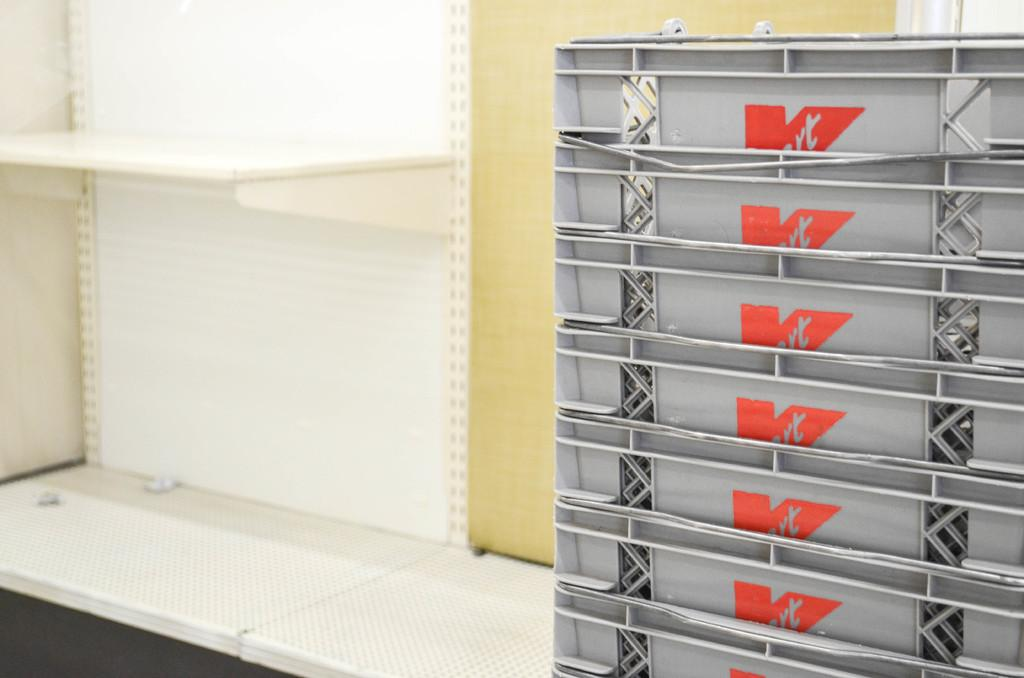<image>
Write a terse but informative summary of the picture. Several K mart shopping baskets are stacked on an empty counter. 